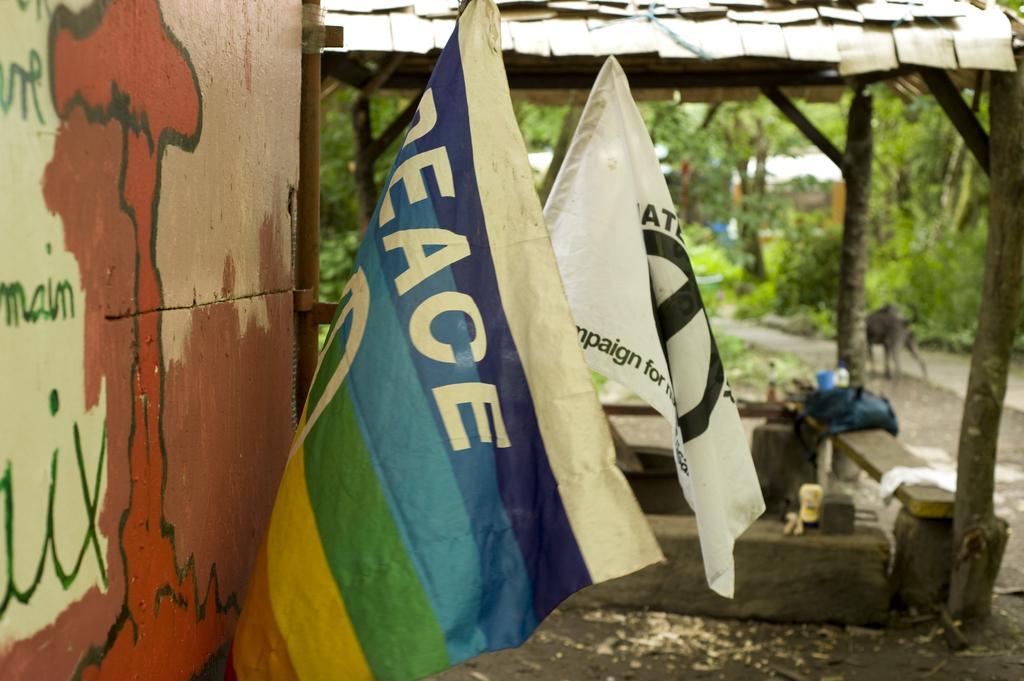How would you summarize this image in a sentence or two? In this image we can see the flags attached to the board. And we can see the shed and wooden benches, on the bench we can see the cup, bottle, cloth and few objects on it. We can see the animal standing on the ground and there are trees. 